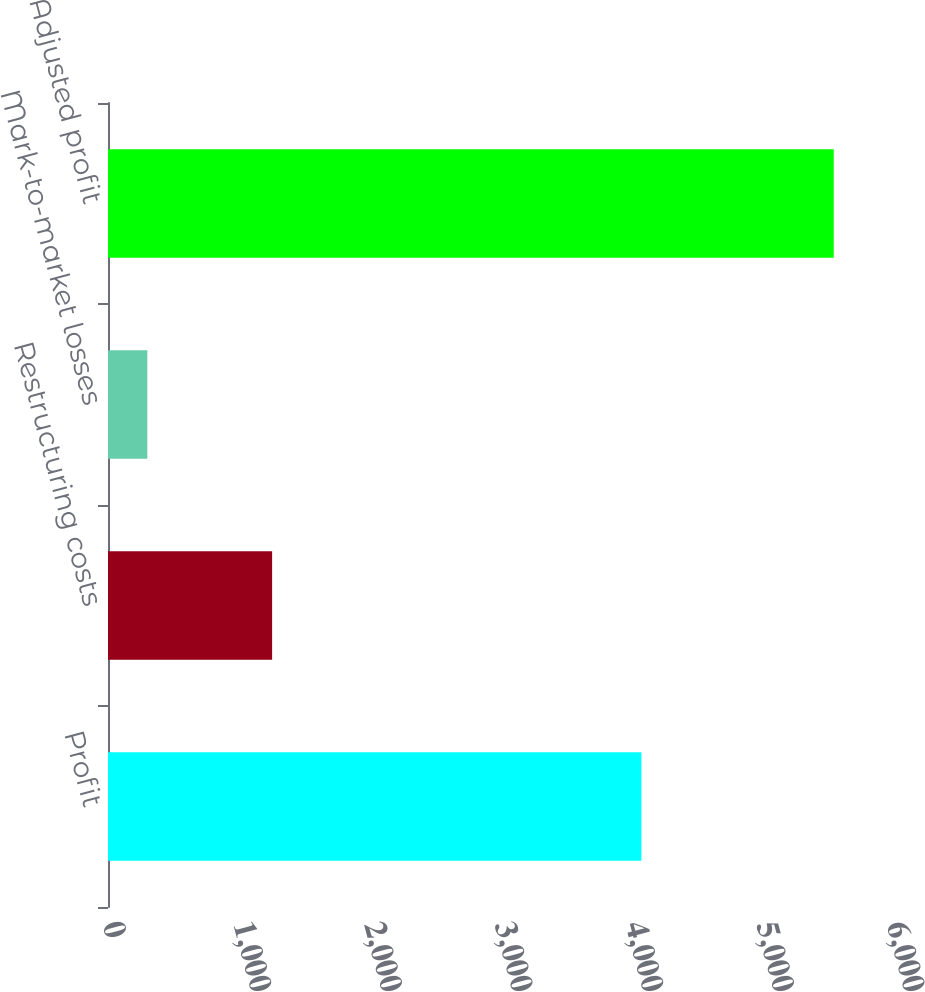Convert chart. <chart><loc_0><loc_0><loc_500><loc_500><bar_chart><fcel>Profit<fcel>Restructuring costs<fcel>Mark-to-market losses<fcel>Adjusted profit<nl><fcel>4082<fcel>1256<fcel>301<fcel>5554<nl></chart> 